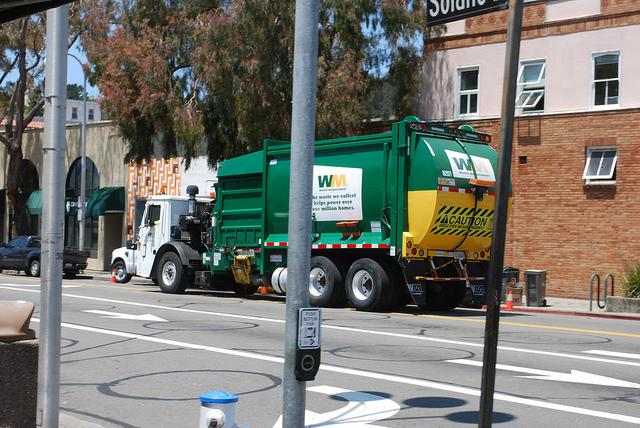What kind of product is likely hauled by the green truck? trash 